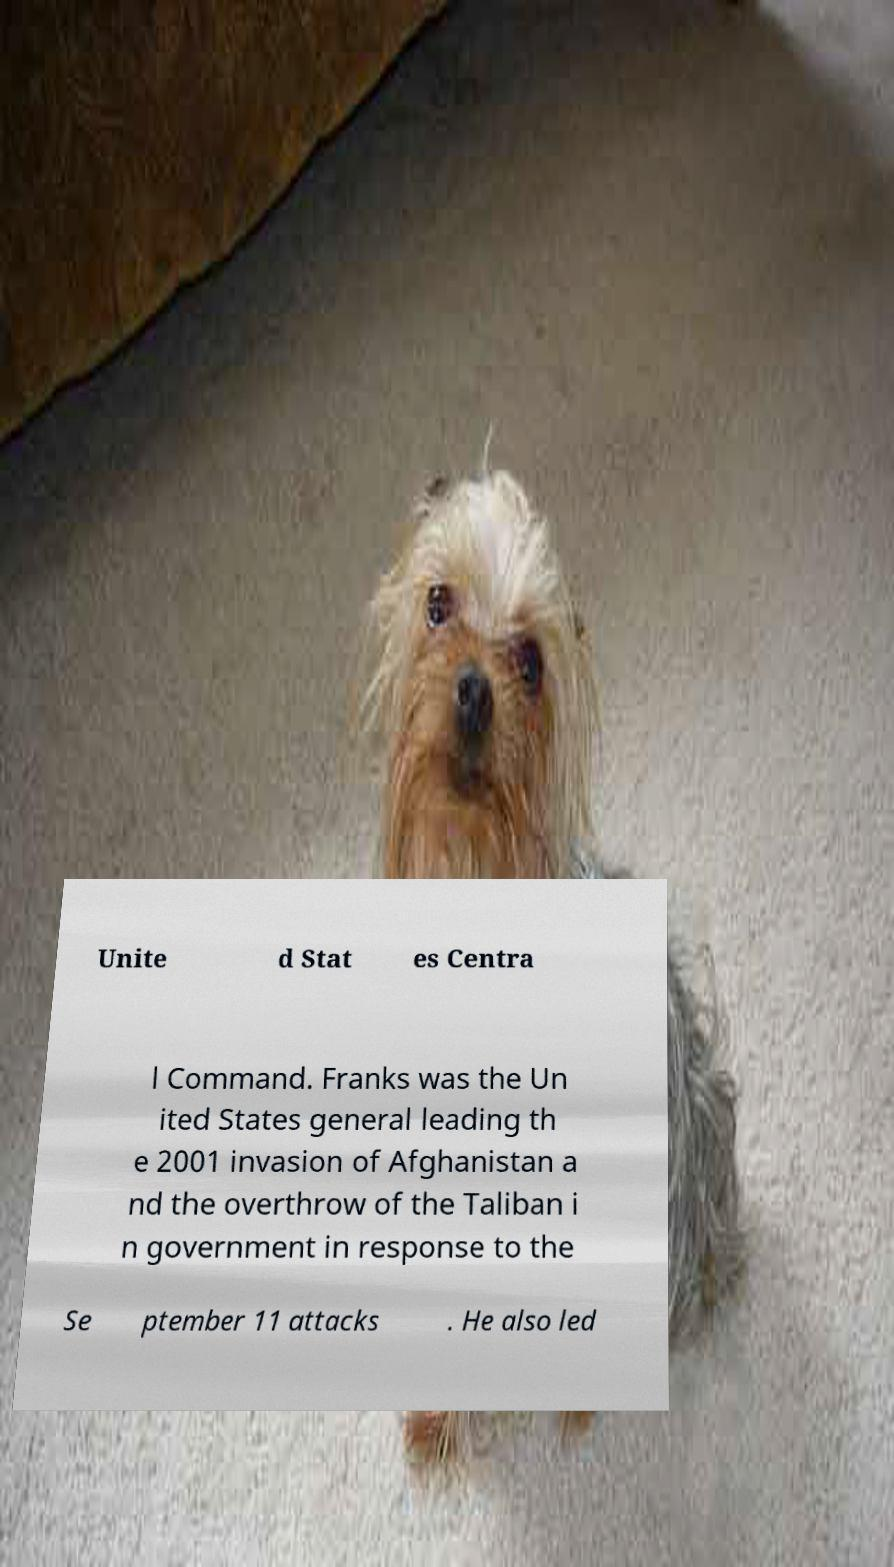What messages or text are displayed in this image? I need them in a readable, typed format. Unite d Stat es Centra l Command. Franks was the Un ited States general leading th e 2001 invasion of Afghanistan a nd the overthrow of the Taliban i n government in response to the Se ptember 11 attacks . He also led 